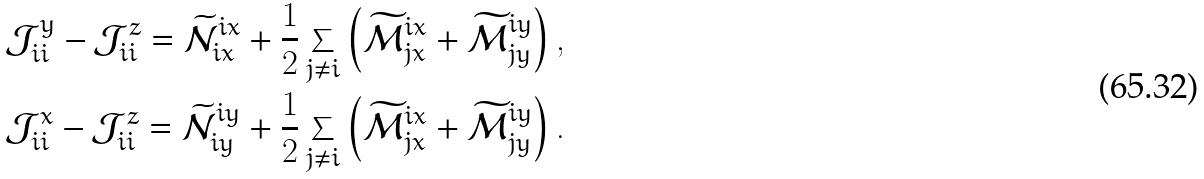<formula> <loc_0><loc_0><loc_500><loc_500>& \mathcal { J } _ { i i } ^ { y } - \mathcal { J } _ { i i } ^ { z } = \widetilde { \mathcal { N } } ^ { i x } _ { i x } + \frac { 1 } { 2 } \sum _ { j \neq i } \left ( \widetilde { \mathcal { M } } ^ { i x } _ { j x } + \widetilde { \mathcal { M } } ^ { i y } _ { j y } \right ) , \\ & \mathcal { J } _ { i i } ^ { x } - \mathcal { J } _ { i i } ^ { z } = \widetilde { \mathcal { N } } ^ { i y } _ { i y } + \frac { 1 } { 2 } \sum _ { j \neq i } \left ( \widetilde { \mathcal { M } } ^ { i x } _ { j x } + \widetilde { \mathcal { M } } ^ { i y } _ { j y } \right ) .</formula> 